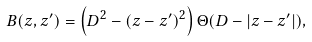<formula> <loc_0><loc_0><loc_500><loc_500>B ( z , z ^ { \prime } ) = \left ( D ^ { 2 } - ( z - z ^ { \prime } ) ^ { 2 } \right ) \Theta ( D - | z - z ^ { \prime } | ) ,</formula> 